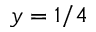Convert formula to latex. <formula><loc_0><loc_0><loc_500><loc_500>y = 1 / 4</formula> 